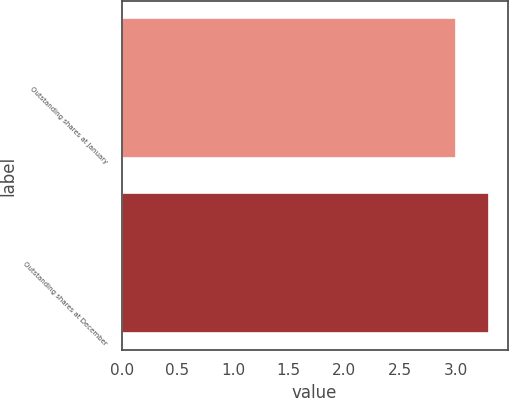<chart> <loc_0><loc_0><loc_500><loc_500><bar_chart><fcel>Outstanding shares at January<fcel>Outstanding shares at December<nl><fcel>3<fcel>3.3<nl></chart> 